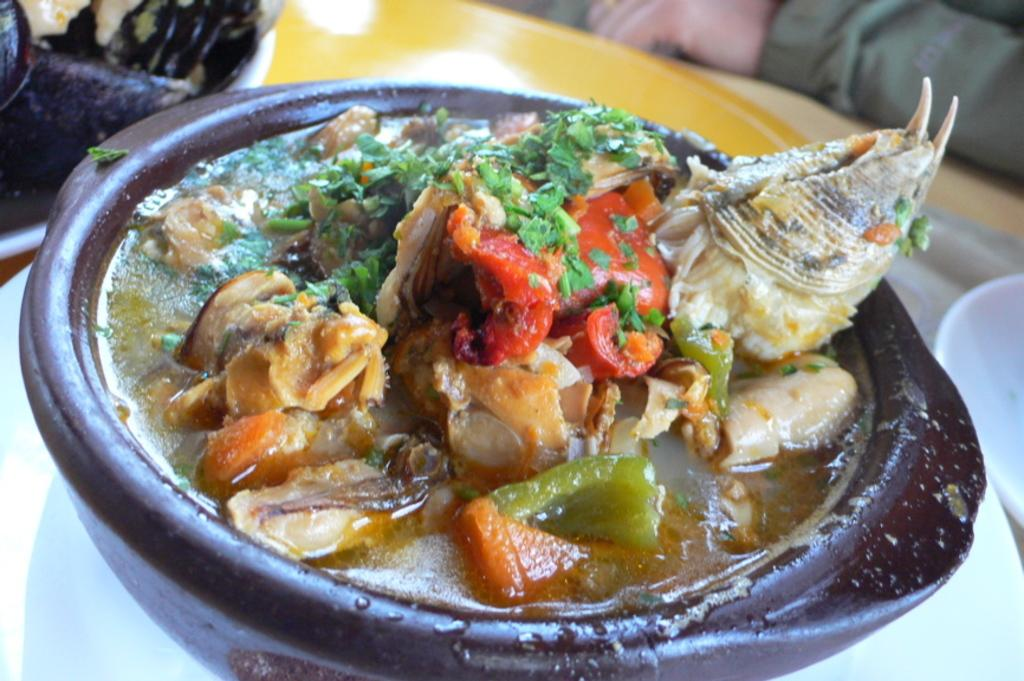What objects are present on the table in the image? There are plates and a bowl on the table in the image. What is inside the bowl? There are food items in the bowl. Can you describe any other visible elements in the image? A person's hand is visible at the side. What type of yard can be seen in the background of the image? There is no yard visible in the image; it only shows objects on a table. 